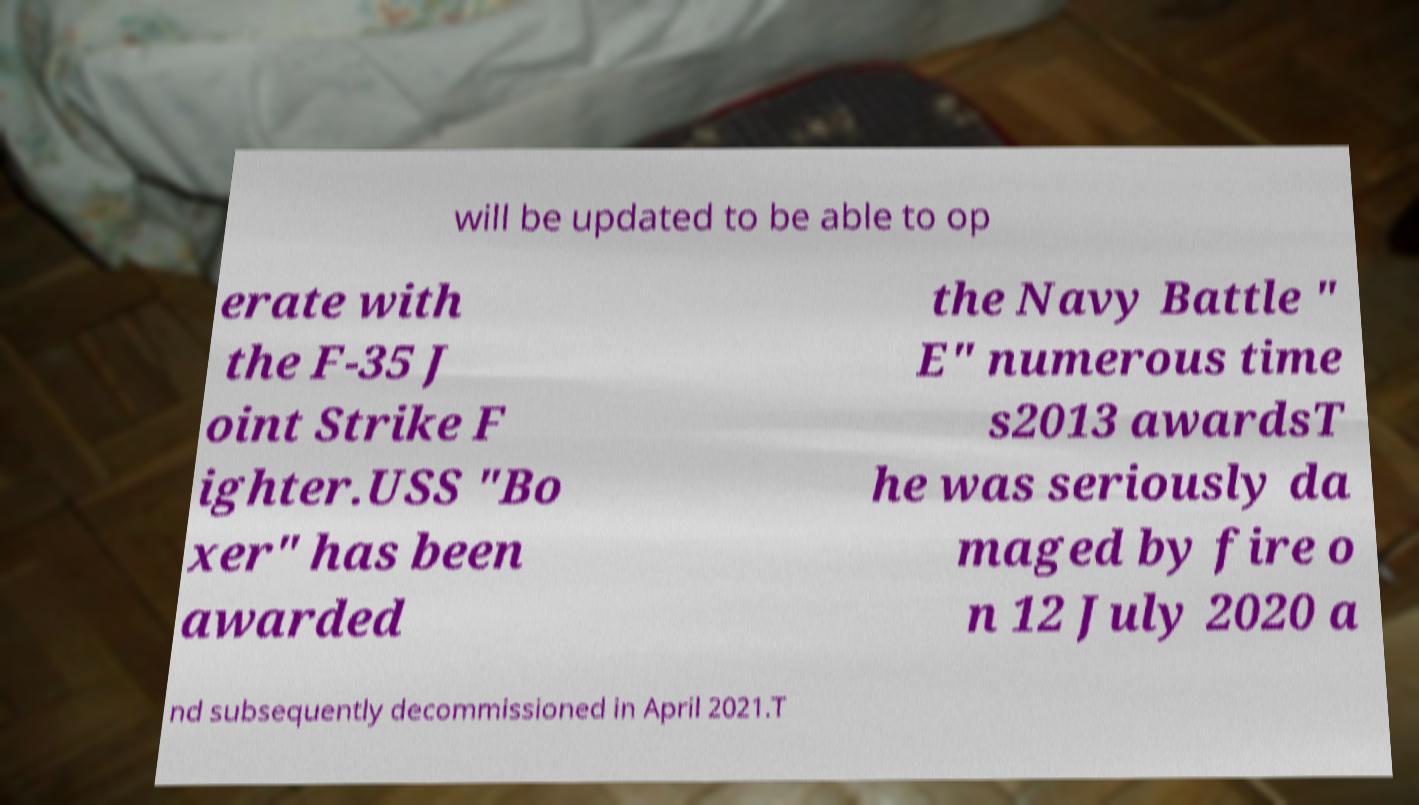Please read and relay the text visible in this image. What does it say? will be updated to be able to op erate with the F-35 J oint Strike F ighter.USS "Bo xer" has been awarded the Navy Battle " E" numerous time s2013 awardsT he was seriously da maged by fire o n 12 July 2020 a nd subsequently decommissioned in April 2021.T 